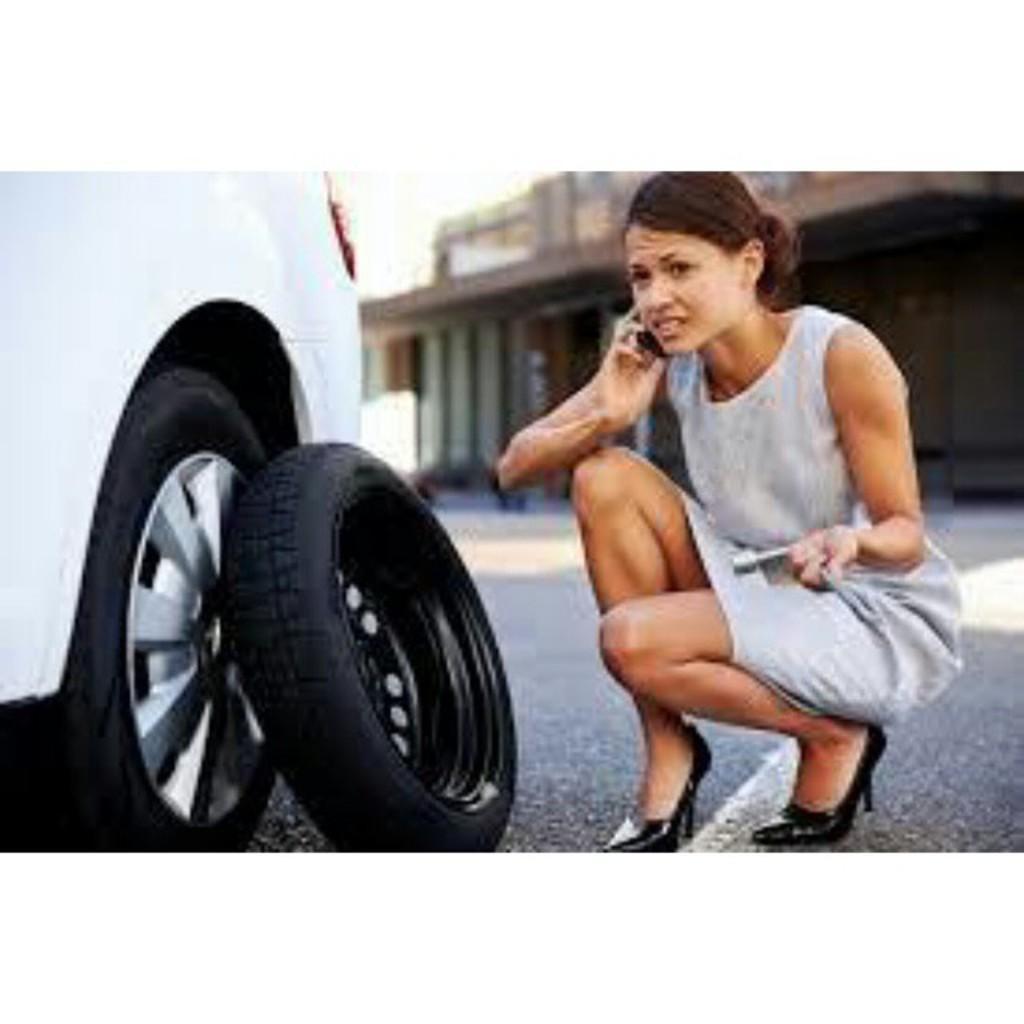In one or two sentences, can you explain what this image depicts? This woman is holding a mobile near her ear. In-front of this vehicle wheel there is a tire. Background it is blur. 